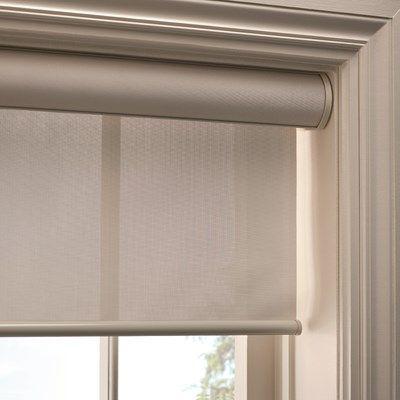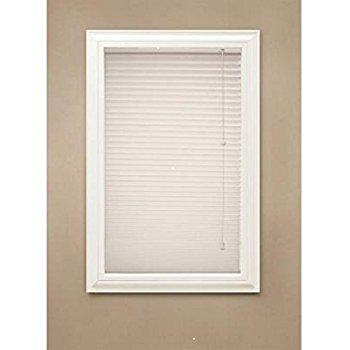The first image is the image on the left, the second image is the image on the right. Considering the images on both sides, is "An image shows a tufted chair on the left in front of side-by-side windows with shades that are not fully closed." valid? Answer yes or no. No. The first image is the image on the left, the second image is the image on the right. Considering the images on both sides, is "There is a table in the right image, and a light to the left of the table." valid? Answer yes or no. No. 